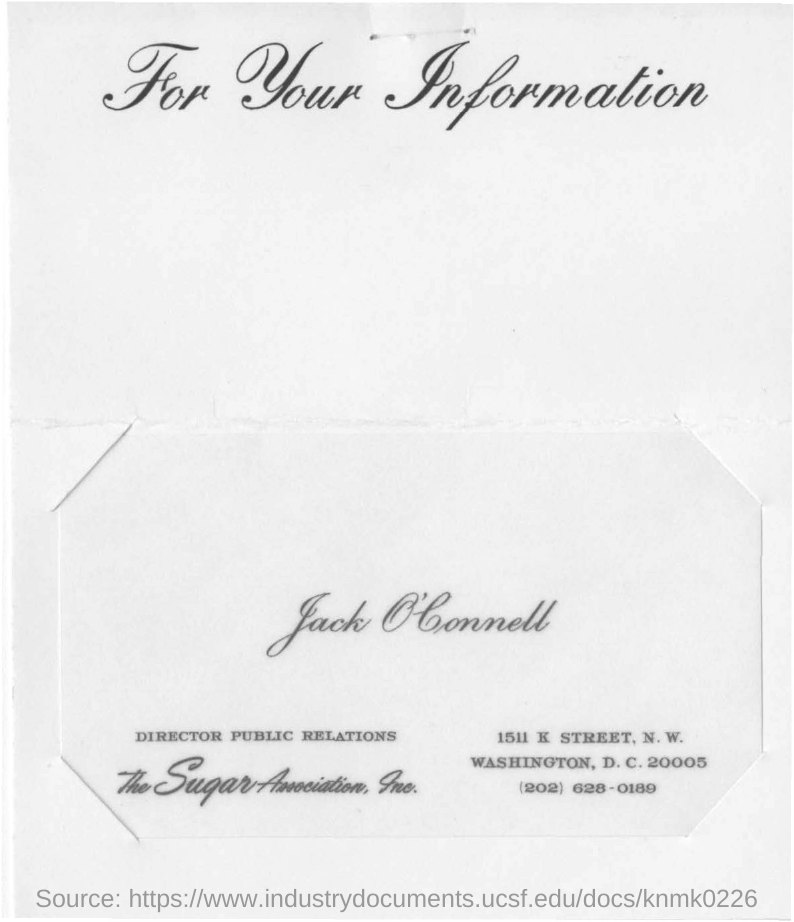What is written at the top?
Provide a succinct answer. For Your Information. Who is the director public relations for the sugar association, Inc?
Offer a terse response. Jack O'Connell. What is the designation of jack o' connell?
Keep it short and to the point. DIRECTOR PUBLIC RELATIONS. Where is he located at?
Give a very brief answer. Washington, D. C. What is the telephone number of jack o'connell?
Offer a very short reply. (202) 628-0189. 